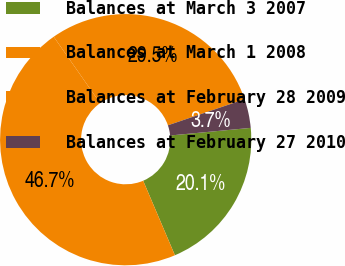Convert chart to OTSL. <chart><loc_0><loc_0><loc_500><loc_500><pie_chart><fcel>Balances at March 3 2007<fcel>Balances at March 1 2008<fcel>Balances at February 28 2009<fcel>Balances at February 27 2010<nl><fcel>20.09%<fcel>46.7%<fcel>29.49%<fcel>3.72%<nl></chart> 